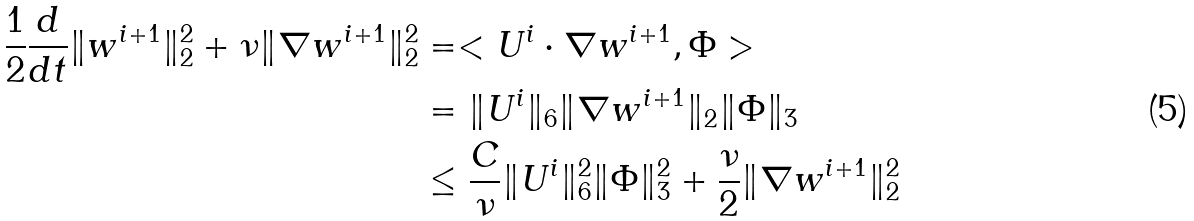Convert formula to latex. <formula><loc_0><loc_0><loc_500><loc_500>\frac { 1 } { 2 } \frac { d } { d t } \| w ^ { i + 1 } \| _ { 2 } ^ { 2 } + \nu \| \nabla w ^ { i + 1 } \| _ { 2 } ^ { 2 } & = < U ^ { i } \cdot \nabla w ^ { i + 1 } , \Phi > \\ & = \| U ^ { i } \| _ { 6 } \| \nabla w ^ { i + 1 } \| _ { 2 } \| \Phi \| _ { 3 } \\ & \leq \frac { C } { \nu } \| U ^ { i } \| ^ { 2 } _ { 6 } \| \Phi \| ^ { 2 } _ { 3 } + \frac { \nu } { 2 } \| \nabla w ^ { i + 1 } \| _ { 2 } ^ { 2 }</formula> 